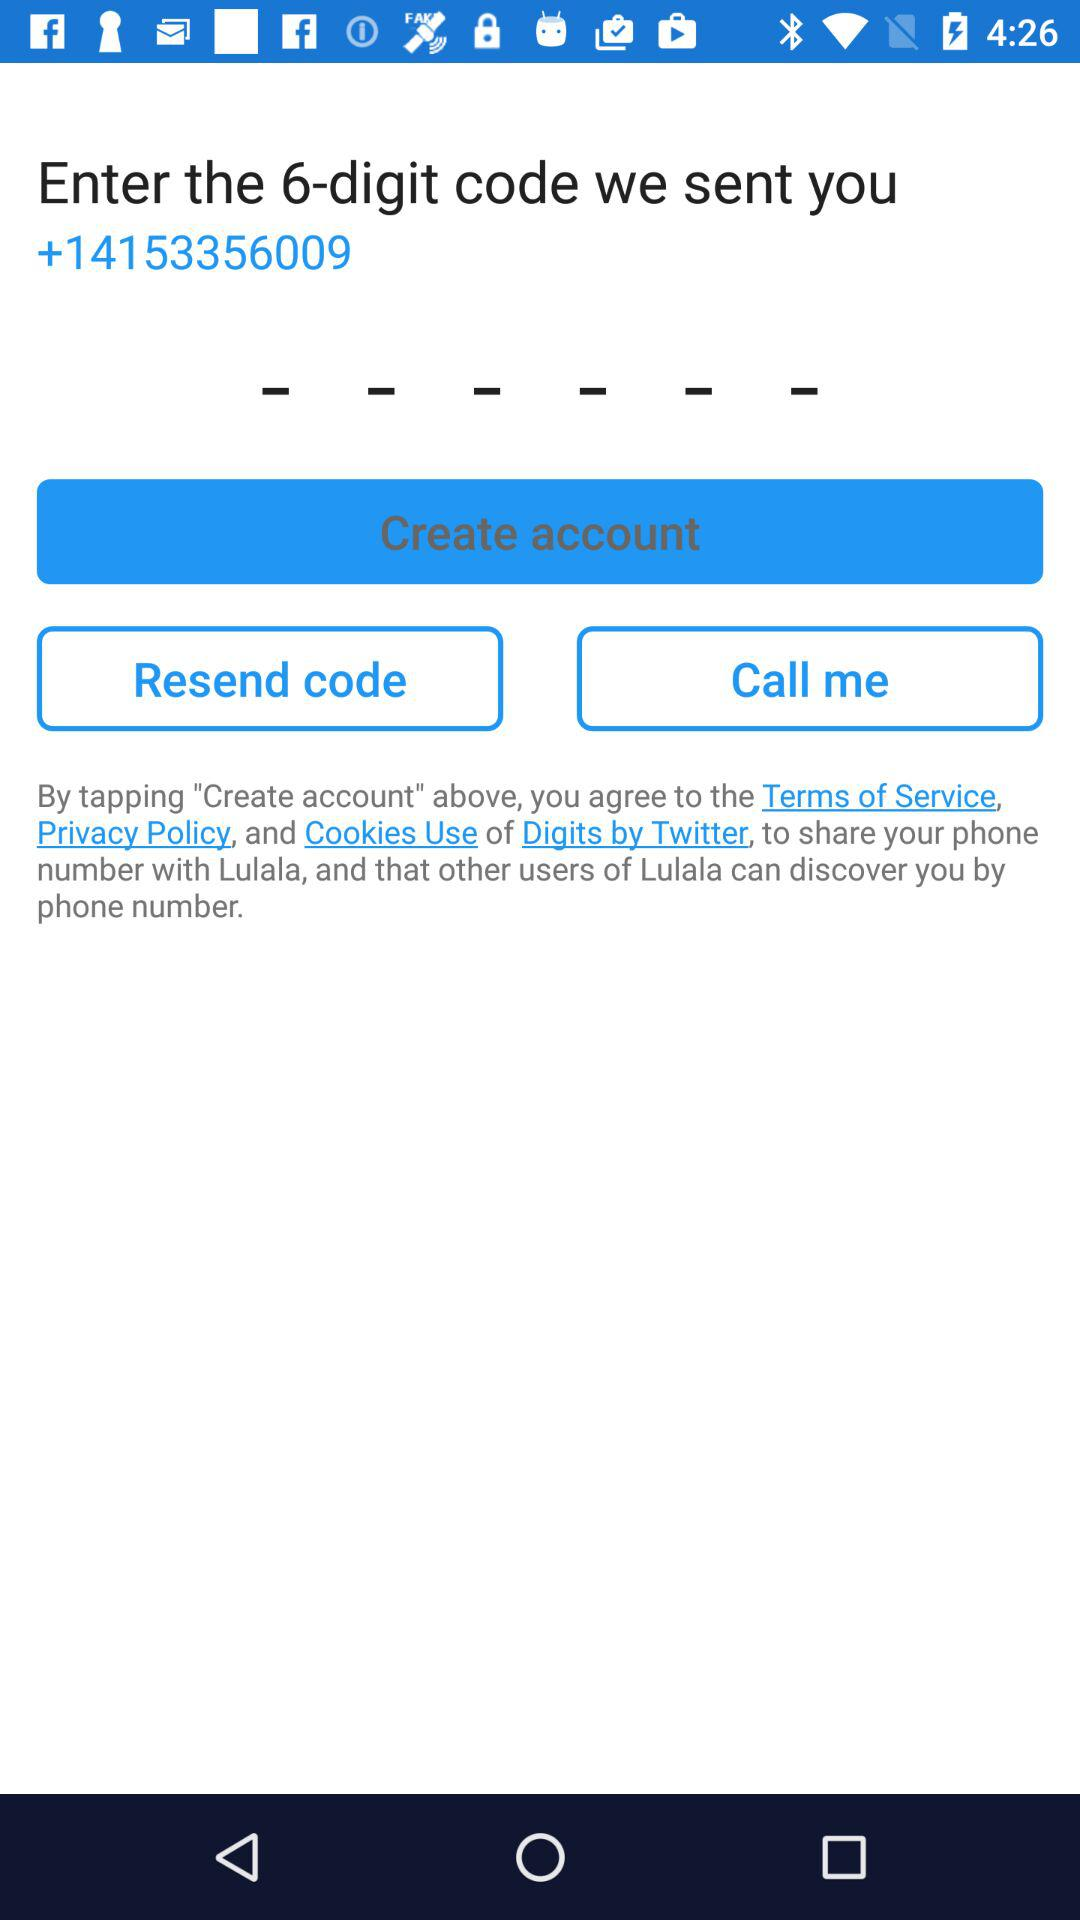How many digits are there in the code? There are 6 digits in the code. 